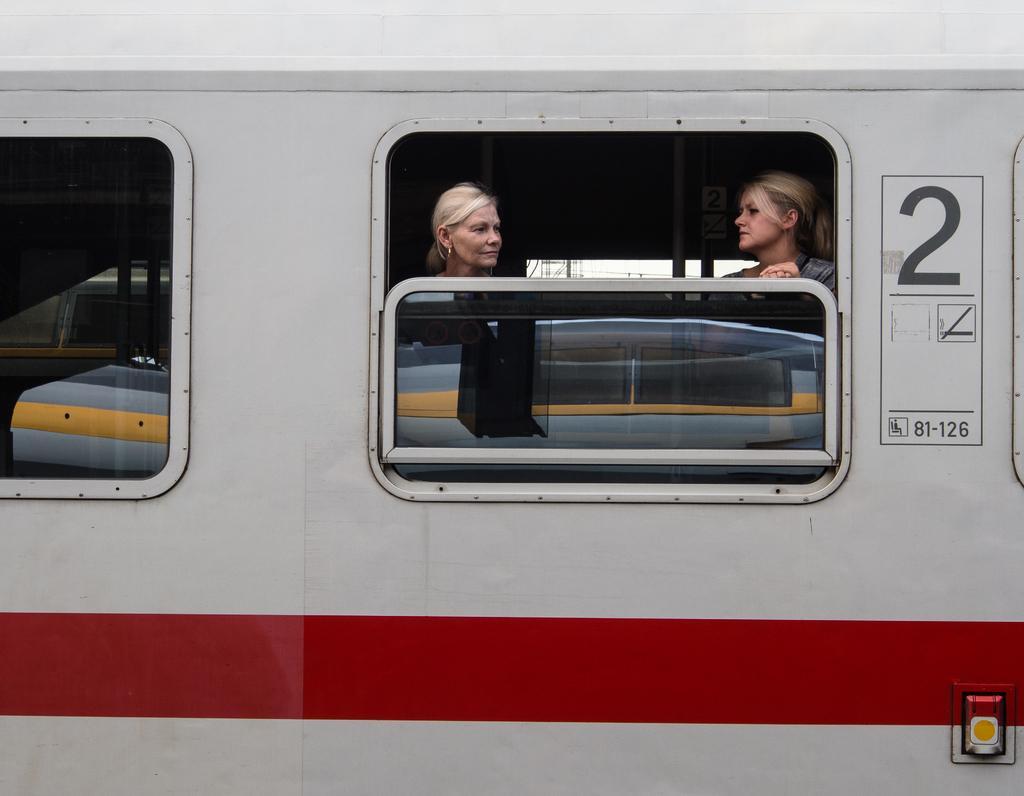How would you summarize this image in a sentence or two? Here we can see two women at the window door inside the train and we can another window,text written on the train and an object on the train. In the background we can see poles and some other objects. 